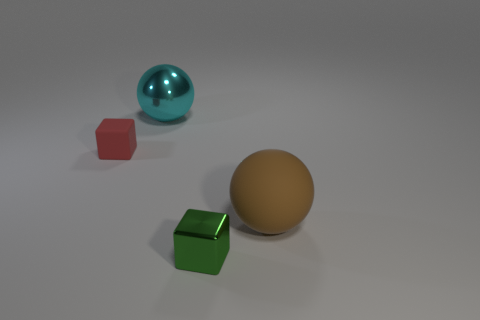There is a cyan sphere that is made of the same material as the green cube; what is its size?
Give a very brief answer. Large. Does the block that is right of the tiny red matte object have the same size as the sphere in front of the cyan metal ball?
Provide a short and direct response. No. There is another thing that is the same shape as the large cyan object; what is its size?
Provide a short and direct response. Large. What color is the big thing that is left of the large object that is to the right of the large metal object?
Your response must be concise. Cyan. The thing that is both left of the large brown thing and in front of the matte block is made of what material?
Offer a terse response. Metal. Are there any green metal objects that have the same shape as the tiny red matte thing?
Make the answer very short. Yes. Do the rubber thing right of the small red thing and the big cyan shiny thing have the same shape?
Offer a very short reply. Yes. What number of objects are both in front of the cyan object and on the left side of the tiny shiny block?
Offer a terse response. 1. There is a rubber object to the left of the large metal thing; what is its shape?
Give a very brief answer. Cube. How many other small objects are the same material as the cyan object?
Offer a terse response. 1. 